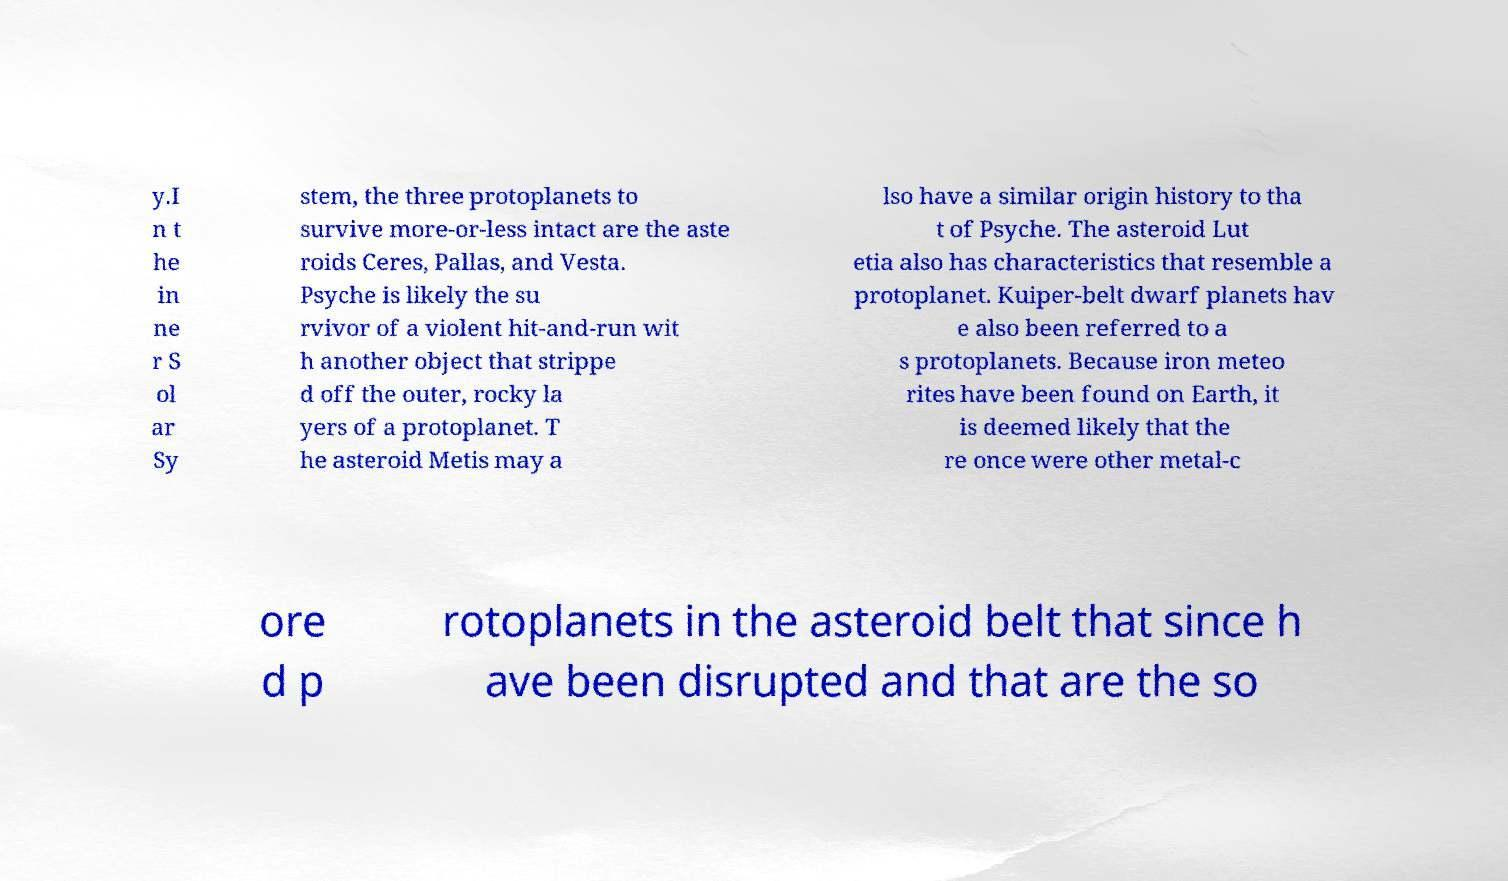Could you extract and type out the text from this image? y.I n t he in ne r S ol ar Sy stem, the three protoplanets to survive more-or-less intact are the aste roids Ceres, Pallas, and Vesta. Psyche is likely the su rvivor of a violent hit-and-run wit h another object that strippe d off the outer, rocky la yers of a protoplanet. T he asteroid Metis may a lso have a similar origin history to tha t of Psyche. The asteroid Lut etia also has characteristics that resemble a protoplanet. Kuiper-belt dwarf planets hav e also been referred to a s protoplanets. Because iron meteo rites have been found on Earth, it is deemed likely that the re once were other metal-c ore d p rotoplanets in the asteroid belt that since h ave been disrupted and that are the so 